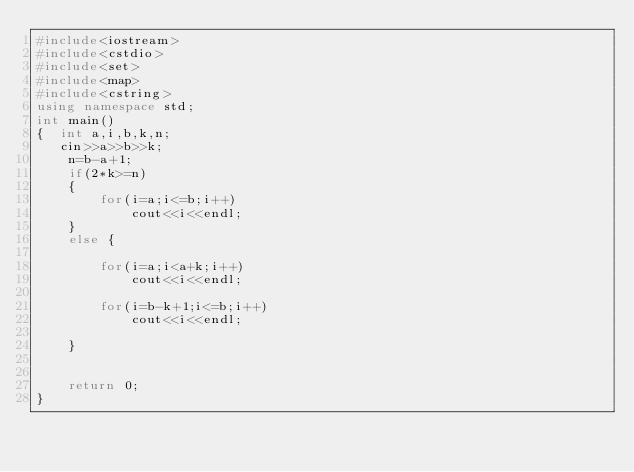Convert code to text. <code><loc_0><loc_0><loc_500><loc_500><_C++_>#include<iostream>
#include<cstdio>
#include<set>
#include<map>
#include<cstring>
using namespace std;
int main()
{  int a,i,b,k,n;
   cin>>a>>b>>k;
    n=b-a+1;
    if(2*k>=n)
    {
        for(i=a;i<=b;i++)
            cout<<i<<endl;
    }
    else {

        for(i=a;i<a+k;i++)
            cout<<i<<endl;

        for(i=b-k+1;i<=b;i++)
            cout<<i<<endl;

    }


    return 0;
}

</code> 